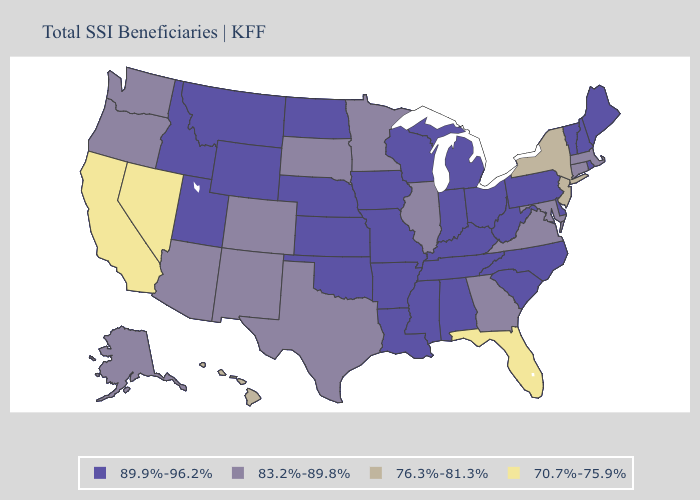Name the states that have a value in the range 83.2%-89.8%?
Be succinct. Alaska, Arizona, Colorado, Connecticut, Georgia, Illinois, Maryland, Massachusetts, Minnesota, New Mexico, Oregon, South Dakota, Texas, Virginia, Washington. Does Maine have the lowest value in the Northeast?
Short answer required. No. Which states hav the highest value in the South?
Keep it brief. Alabama, Arkansas, Delaware, Kentucky, Louisiana, Mississippi, North Carolina, Oklahoma, South Carolina, Tennessee, West Virginia. Name the states that have a value in the range 83.2%-89.8%?
Concise answer only. Alaska, Arizona, Colorado, Connecticut, Georgia, Illinois, Maryland, Massachusetts, Minnesota, New Mexico, Oregon, South Dakota, Texas, Virginia, Washington. Which states have the lowest value in the USA?
Short answer required. California, Florida, Nevada. Among the states that border New York , which have the highest value?
Short answer required. Pennsylvania, Vermont. What is the value of Idaho?
Keep it brief. 89.9%-96.2%. Does Georgia have a higher value than Rhode Island?
Answer briefly. No. What is the value of Rhode Island?
Give a very brief answer. 89.9%-96.2%. Which states have the lowest value in the MidWest?
Be succinct. Illinois, Minnesota, South Dakota. Does the first symbol in the legend represent the smallest category?
Be succinct. No. Does the map have missing data?
Keep it brief. No. What is the value of Oregon?
Keep it brief. 83.2%-89.8%. Among the states that border Ohio , which have the lowest value?
Give a very brief answer. Indiana, Kentucky, Michigan, Pennsylvania, West Virginia. Among the states that border North Carolina , does Georgia have the highest value?
Answer briefly. No. 